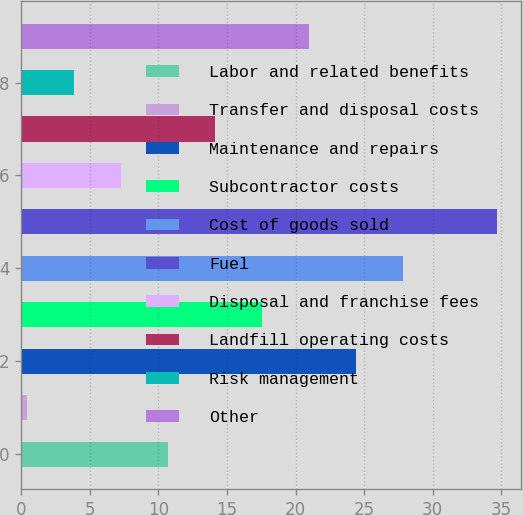<chart> <loc_0><loc_0><loc_500><loc_500><bar_chart><fcel>Labor and related benefits<fcel>Transfer and disposal costs<fcel>Maintenance and repairs<fcel>Subcontractor costs<fcel>Cost of goods sold<fcel>Fuel<fcel>Disposal and franchise fees<fcel>Landfill operating costs<fcel>Risk management<fcel>Other<nl><fcel>10.69<fcel>0.4<fcel>24.41<fcel>17.55<fcel>27.84<fcel>34.7<fcel>7.26<fcel>14.12<fcel>3.83<fcel>20.98<nl></chart> 